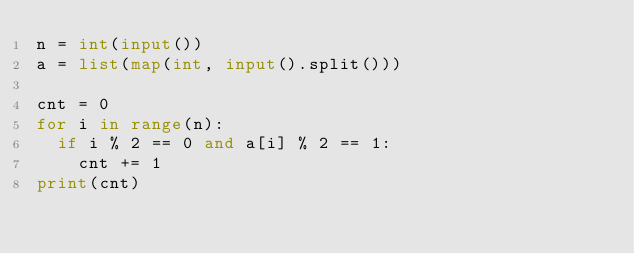<code> <loc_0><loc_0><loc_500><loc_500><_Python_>n = int(input())
a = list(map(int, input().split()))

cnt = 0
for i in range(n):
  if i % 2 == 0 and a[i] % 2 == 1:
    cnt += 1
print(cnt)</code> 